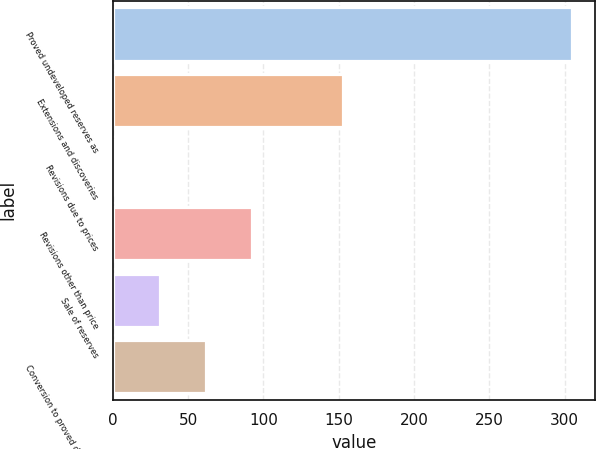Convert chart. <chart><loc_0><loc_0><loc_500><loc_500><bar_chart><fcel>Proved undeveloped reserves as<fcel>Extensions and discoveries<fcel>Revisions due to prices<fcel>Revisions other than price<fcel>Sale of reserves<fcel>Conversion to proved developed<nl><fcel>305<fcel>153<fcel>1<fcel>92.2<fcel>31.4<fcel>61.8<nl></chart> 